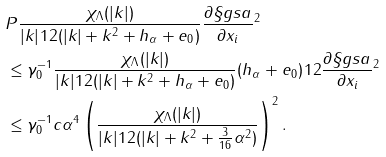Convert formula to latex. <formula><loc_0><loc_0><loc_500><loc_500>& \| P \frac { \chi _ { \Lambda } ( | k | ) } { | k | ^ { } { 1 } 2 ( | k | + k ^ { 2 } + h _ { \alpha } + e _ { 0 } ) } \frac { \partial \S g s a } { \partial x _ { i } } \| ^ { 2 } \\ & \leq \gamma _ { 0 } ^ { - 1 } \| \frac { \chi _ { \Lambda } ( | k | ) } { | k | ^ { } { 1 } 2 ( | k | + k ^ { 2 } + h _ { \alpha } + e _ { 0 } ) } ( h _ { \alpha } + e _ { 0 } ) ^ { } { 1 } 2 \frac { \partial \S g s a } { \partial x _ { i } } \| ^ { 2 } \\ & \leq \gamma _ { 0 } ^ { - 1 } c \alpha ^ { 4 } \left ( \frac { \chi _ { \Lambda } ( | k | ) } { | k | ^ { } { 1 } 2 ( | k | + k ^ { 2 } + \frac { 3 } { 1 6 } \alpha ^ { 2 } ) } \right ) ^ { 2 } .</formula> 